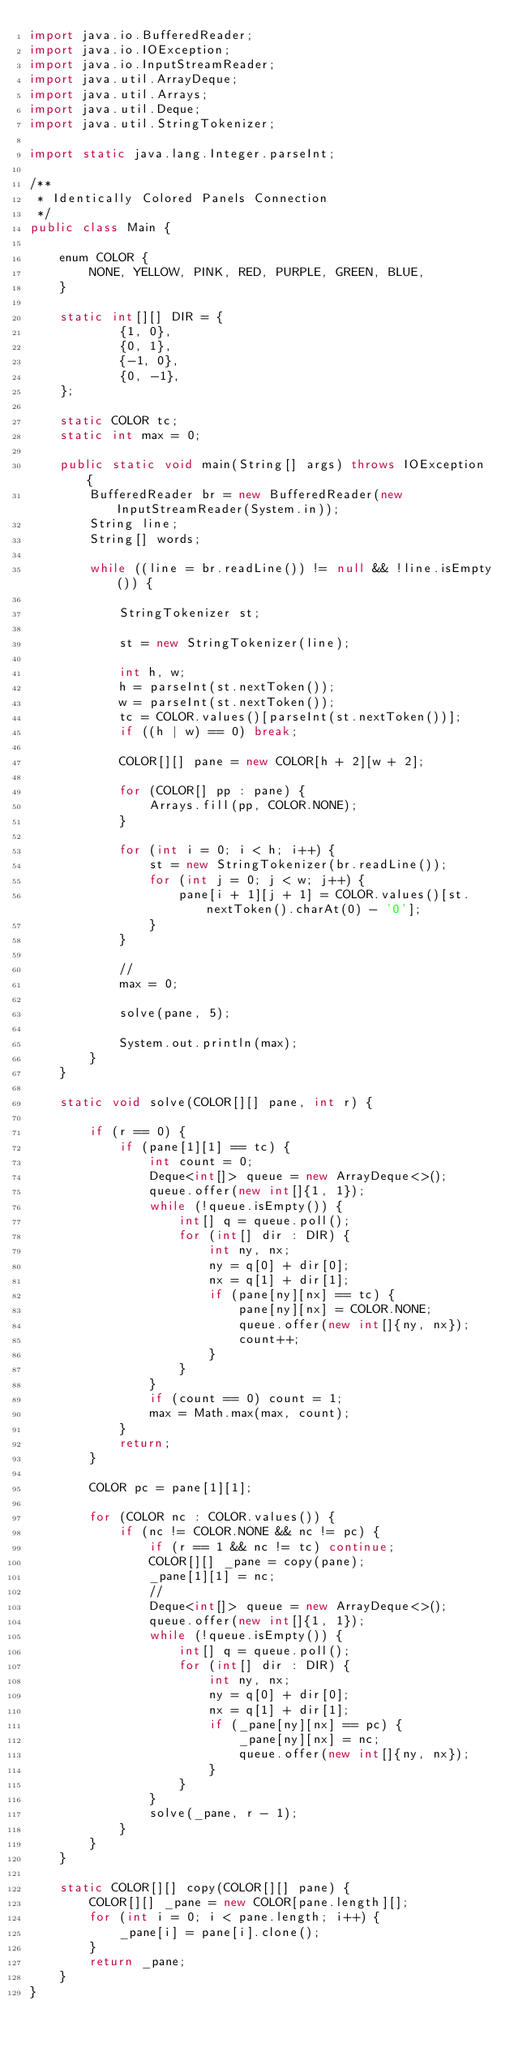<code> <loc_0><loc_0><loc_500><loc_500><_Java_>import java.io.BufferedReader;
import java.io.IOException;
import java.io.InputStreamReader;
import java.util.ArrayDeque;
import java.util.Arrays;
import java.util.Deque;
import java.util.StringTokenizer;

import static java.lang.Integer.parseInt;

/**
 * Identically Colored Panels Connection
 */
public class Main {

	enum COLOR {
		NONE, YELLOW, PINK, RED, PURPLE, GREEN, BLUE,
	}

	static int[][] DIR = {
			{1, 0},
			{0, 1},
			{-1, 0},
			{0, -1},
	};

	static COLOR tc;
	static int max = 0;

	public static void main(String[] args) throws IOException {
		BufferedReader br = new BufferedReader(new InputStreamReader(System.in));
		String line;
		String[] words;

		while ((line = br.readLine()) != null && !line.isEmpty()) {

			StringTokenizer st;

			st = new StringTokenizer(line);

			int h, w;
			h = parseInt(st.nextToken());
			w = parseInt(st.nextToken());
			tc = COLOR.values()[parseInt(st.nextToken())];
			if ((h | w) == 0) break;

			COLOR[][] pane = new COLOR[h + 2][w + 2];

			for (COLOR[] pp : pane) {
				Arrays.fill(pp, COLOR.NONE);
			}

			for (int i = 0; i < h; i++) {
				st = new StringTokenizer(br.readLine());
				for (int j = 0; j < w; j++) {
					pane[i + 1][j + 1] = COLOR.values()[st.nextToken().charAt(0) - '0'];
				}
			}

			//
			max = 0;

			solve(pane, 5);

			System.out.println(max);
		}
	}

	static void solve(COLOR[][] pane, int r) {

		if (r == 0) {
			if (pane[1][1] == tc) {
				int count = 0;
				Deque<int[]> queue = new ArrayDeque<>();
				queue.offer(new int[]{1, 1});
				while (!queue.isEmpty()) {
					int[] q = queue.poll();
					for (int[] dir : DIR) {
						int ny, nx;
						ny = q[0] + dir[0];
						nx = q[1] + dir[1];
						if (pane[ny][nx] == tc) {
							pane[ny][nx] = COLOR.NONE;
							queue.offer(new int[]{ny, nx});
							count++;
						}
					}
				}
				if (count == 0) count = 1;
				max = Math.max(max, count);
			}
			return;
		}

		COLOR pc = pane[1][1];

		for (COLOR nc : COLOR.values()) {
			if (nc != COLOR.NONE && nc != pc) {
				if (r == 1 && nc != tc) continue;
				COLOR[][] _pane = copy(pane);
				_pane[1][1] = nc;
				//
				Deque<int[]> queue = new ArrayDeque<>();
				queue.offer(new int[]{1, 1});
				while (!queue.isEmpty()) {
					int[] q = queue.poll();
					for (int[] dir : DIR) {
						int ny, nx;
						ny = q[0] + dir[0];
						nx = q[1] + dir[1];
						if (_pane[ny][nx] == pc) {
							_pane[ny][nx] = nc;
							queue.offer(new int[]{ny, nx});
						}
					}
				}
				solve(_pane, r - 1);
			}
		}
	}

	static COLOR[][] copy(COLOR[][] pane) {
		COLOR[][] _pane = new COLOR[pane.length][];
		for (int i = 0; i < pane.length; i++) {
			_pane[i] = pane[i].clone();
		}
		return _pane;
	}
}</code> 